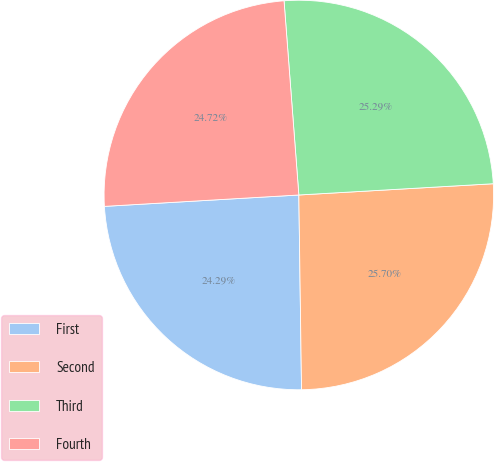Convert chart to OTSL. <chart><loc_0><loc_0><loc_500><loc_500><pie_chart><fcel>First<fcel>Second<fcel>Third<fcel>Fourth<nl><fcel>24.29%<fcel>25.7%<fcel>25.29%<fcel>24.72%<nl></chart> 